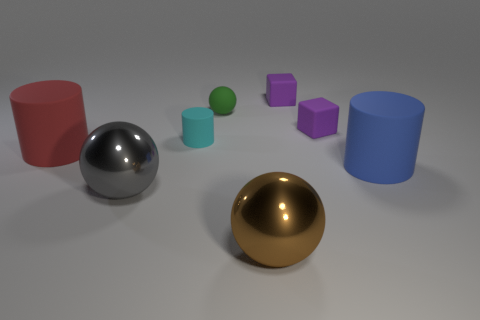How do the colors of the objects contribute to the composition? The colors of the objects – cyan, red, and purple among others – are distinct and visually separate each form, making it easy to distinguish the individual shapes. The varied hues add visual interest to the composition and demonstrate the rendering capabilities of the software used to create the image. 